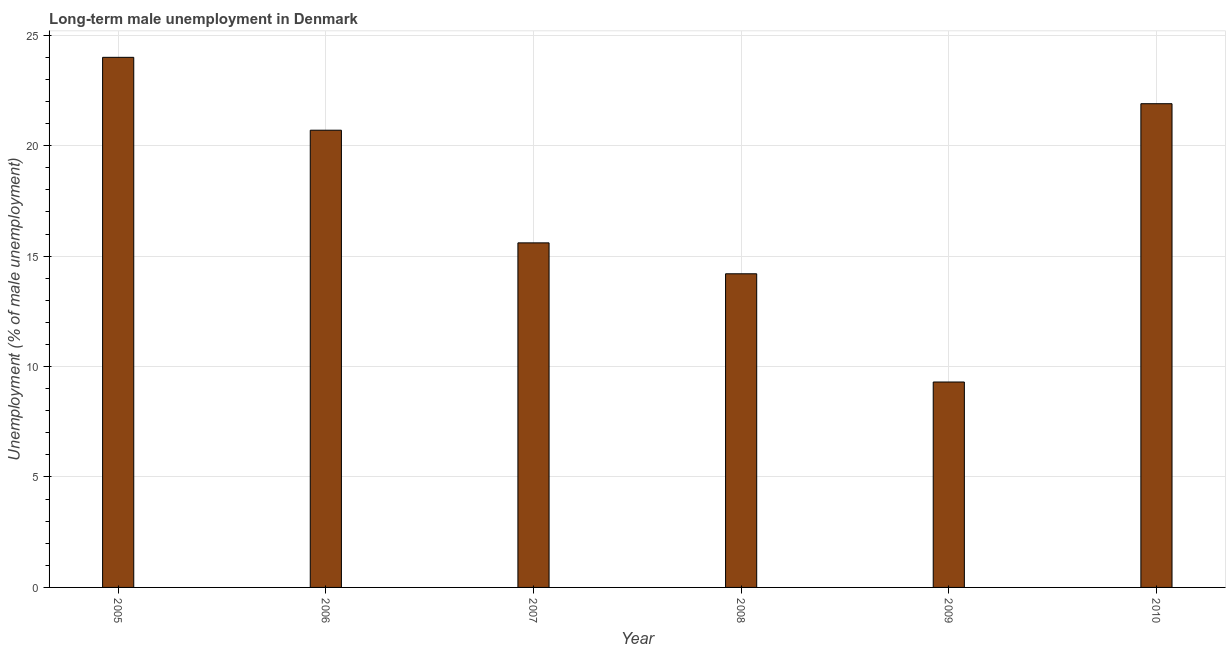Does the graph contain grids?
Offer a terse response. Yes. What is the title of the graph?
Ensure brevity in your answer.  Long-term male unemployment in Denmark. What is the label or title of the Y-axis?
Offer a very short reply. Unemployment (% of male unemployment). What is the long-term male unemployment in 2009?
Provide a short and direct response. 9.3. Across all years, what is the minimum long-term male unemployment?
Offer a terse response. 9.3. In which year was the long-term male unemployment maximum?
Offer a terse response. 2005. What is the sum of the long-term male unemployment?
Your answer should be compact. 105.7. What is the difference between the long-term male unemployment in 2007 and 2008?
Your response must be concise. 1.4. What is the average long-term male unemployment per year?
Offer a very short reply. 17.62. What is the median long-term male unemployment?
Provide a succinct answer. 18.15. In how many years, is the long-term male unemployment greater than 20 %?
Offer a very short reply. 3. Do a majority of the years between 2009 and 2010 (inclusive) have long-term male unemployment greater than 7 %?
Make the answer very short. Yes. What is the ratio of the long-term male unemployment in 2005 to that in 2008?
Your response must be concise. 1.69. What is the difference between the highest and the lowest long-term male unemployment?
Your answer should be very brief. 14.7. Are all the bars in the graph horizontal?
Your answer should be very brief. No. What is the Unemployment (% of male unemployment) in 2006?
Your answer should be very brief. 20.7. What is the Unemployment (% of male unemployment) of 2007?
Your answer should be very brief. 15.6. What is the Unemployment (% of male unemployment) in 2008?
Make the answer very short. 14.2. What is the Unemployment (% of male unemployment) of 2009?
Offer a terse response. 9.3. What is the Unemployment (% of male unemployment) in 2010?
Your answer should be compact. 21.9. What is the difference between the Unemployment (% of male unemployment) in 2005 and 2007?
Keep it short and to the point. 8.4. What is the difference between the Unemployment (% of male unemployment) in 2005 and 2008?
Ensure brevity in your answer.  9.8. What is the difference between the Unemployment (% of male unemployment) in 2005 and 2010?
Your response must be concise. 2.1. What is the difference between the Unemployment (% of male unemployment) in 2006 and 2007?
Make the answer very short. 5.1. What is the difference between the Unemployment (% of male unemployment) in 2006 and 2010?
Offer a very short reply. -1.2. What is the difference between the Unemployment (% of male unemployment) in 2007 and 2008?
Your answer should be compact. 1.4. What is the difference between the Unemployment (% of male unemployment) in 2007 and 2009?
Give a very brief answer. 6.3. What is the difference between the Unemployment (% of male unemployment) in 2007 and 2010?
Keep it short and to the point. -6.3. What is the difference between the Unemployment (% of male unemployment) in 2008 and 2009?
Provide a short and direct response. 4.9. What is the difference between the Unemployment (% of male unemployment) in 2008 and 2010?
Make the answer very short. -7.7. What is the ratio of the Unemployment (% of male unemployment) in 2005 to that in 2006?
Provide a succinct answer. 1.16. What is the ratio of the Unemployment (% of male unemployment) in 2005 to that in 2007?
Offer a very short reply. 1.54. What is the ratio of the Unemployment (% of male unemployment) in 2005 to that in 2008?
Your answer should be compact. 1.69. What is the ratio of the Unemployment (% of male unemployment) in 2005 to that in 2009?
Ensure brevity in your answer.  2.58. What is the ratio of the Unemployment (% of male unemployment) in 2005 to that in 2010?
Keep it short and to the point. 1.1. What is the ratio of the Unemployment (% of male unemployment) in 2006 to that in 2007?
Give a very brief answer. 1.33. What is the ratio of the Unemployment (% of male unemployment) in 2006 to that in 2008?
Offer a terse response. 1.46. What is the ratio of the Unemployment (% of male unemployment) in 2006 to that in 2009?
Your response must be concise. 2.23. What is the ratio of the Unemployment (% of male unemployment) in 2006 to that in 2010?
Offer a very short reply. 0.94. What is the ratio of the Unemployment (% of male unemployment) in 2007 to that in 2008?
Your answer should be compact. 1.1. What is the ratio of the Unemployment (% of male unemployment) in 2007 to that in 2009?
Your answer should be very brief. 1.68. What is the ratio of the Unemployment (% of male unemployment) in 2007 to that in 2010?
Offer a very short reply. 0.71. What is the ratio of the Unemployment (% of male unemployment) in 2008 to that in 2009?
Offer a terse response. 1.53. What is the ratio of the Unemployment (% of male unemployment) in 2008 to that in 2010?
Offer a terse response. 0.65. What is the ratio of the Unemployment (% of male unemployment) in 2009 to that in 2010?
Offer a very short reply. 0.42. 